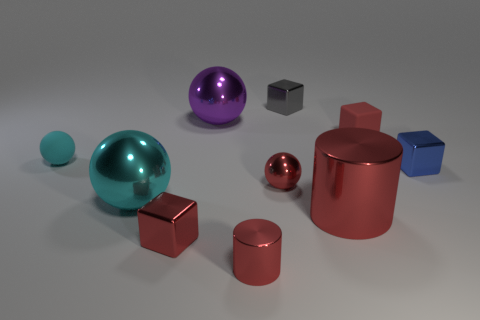Do the small metal sphere and the rubber cube have the same color?
Your response must be concise. Yes. How many things are tiny shiny cylinders that are on the left side of the large shiny cylinder or large purple shiny cylinders?
Make the answer very short. 1. What is the size of the metallic sphere that is behind the small metal sphere?
Your answer should be very brief. Large. What material is the tiny cyan ball?
Keep it short and to the point. Rubber. There is a small red shiny object to the right of the small cylinder in front of the gray thing; what is its shape?
Your answer should be compact. Sphere. How many other things are the same shape as the tiny blue metallic object?
Your answer should be very brief. 3. There is a large purple object; are there any large metallic spheres left of it?
Your answer should be very brief. Yes. What is the color of the big cylinder?
Your answer should be compact. Red. There is a small metallic sphere; is it the same color as the metallic cube that is in front of the blue object?
Ensure brevity in your answer.  Yes. Are there any cyan matte things of the same size as the red rubber cube?
Keep it short and to the point. Yes. 